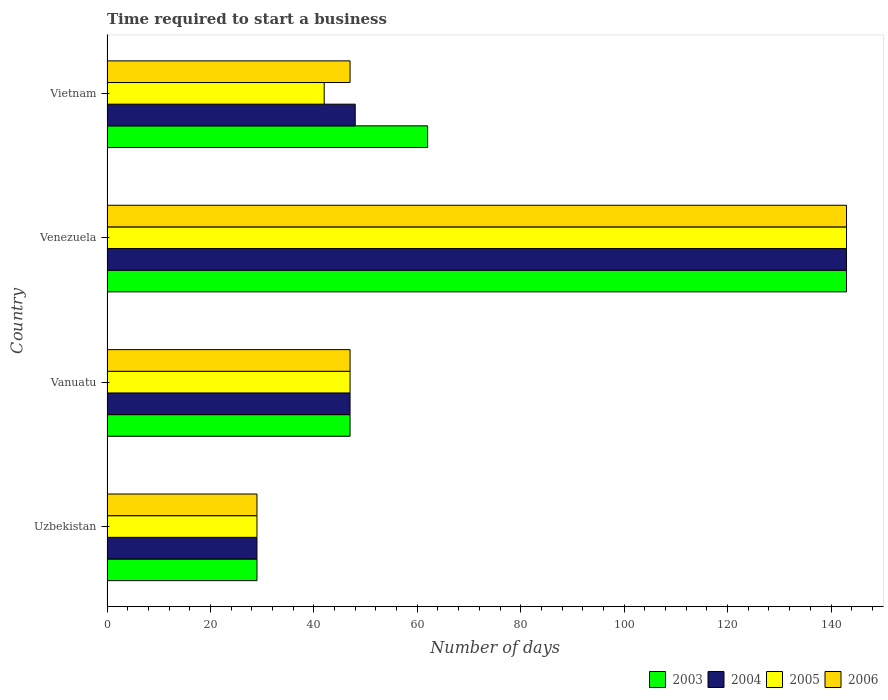Are the number of bars per tick equal to the number of legend labels?
Keep it short and to the point. Yes. Are the number of bars on each tick of the Y-axis equal?
Keep it short and to the point. Yes. How many bars are there on the 3rd tick from the bottom?
Provide a succinct answer. 4. What is the label of the 1st group of bars from the top?
Ensure brevity in your answer.  Vietnam. What is the number of days required to start a business in 2005 in Venezuela?
Provide a succinct answer. 143. Across all countries, what is the maximum number of days required to start a business in 2003?
Offer a very short reply. 143. In which country was the number of days required to start a business in 2003 maximum?
Keep it short and to the point. Venezuela. In which country was the number of days required to start a business in 2005 minimum?
Provide a succinct answer. Uzbekistan. What is the total number of days required to start a business in 2006 in the graph?
Offer a very short reply. 266. What is the difference between the number of days required to start a business in 2004 in Venezuela and that in Vietnam?
Give a very brief answer. 95. What is the difference between the number of days required to start a business in 2006 in Uzbekistan and the number of days required to start a business in 2003 in Vanuatu?
Offer a very short reply. -18. What is the average number of days required to start a business in 2006 per country?
Offer a terse response. 66.5. What is the difference between the number of days required to start a business in 2003 and number of days required to start a business in 2006 in Vanuatu?
Keep it short and to the point. 0. What is the ratio of the number of days required to start a business in 2004 in Uzbekistan to that in Venezuela?
Ensure brevity in your answer.  0.2. Is the difference between the number of days required to start a business in 2003 in Uzbekistan and Vanuatu greater than the difference between the number of days required to start a business in 2006 in Uzbekistan and Vanuatu?
Give a very brief answer. No. What is the difference between the highest and the second highest number of days required to start a business in 2005?
Offer a very short reply. 96. What is the difference between the highest and the lowest number of days required to start a business in 2003?
Provide a succinct answer. 114. In how many countries, is the number of days required to start a business in 2005 greater than the average number of days required to start a business in 2005 taken over all countries?
Give a very brief answer. 1. Is it the case that in every country, the sum of the number of days required to start a business in 2003 and number of days required to start a business in 2006 is greater than the sum of number of days required to start a business in 2005 and number of days required to start a business in 2004?
Provide a succinct answer. No. What does the 3rd bar from the bottom in Vietnam represents?
Ensure brevity in your answer.  2005. How many countries are there in the graph?
Give a very brief answer. 4. What is the difference between two consecutive major ticks on the X-axis?
Your response must be concise. 20. Does the graph contain any zero values?
Offer a very short reply. No. Where does the legend appear in the graph?
Make the answer very short. Bottom right. How many legend labels are there?
Keep it short and to the point. 4. How are the legend labels stacked?
Your answer should be compact. Horizontal. What is the title of the graph?
Provide a succinct answer. Time required to start a business. Does "2012" appear as one of the legend labels in the graph?
Give a very brief answer. No. What is the label or title of the X-axis?
Provide a short and direct response. Number of days. What is the Number of days in 2003 in Uzbekistan?
Provide a short and direct response. 29. What is the Number of days in 2004 in Uzbekistan?
Offer a very short reply. 29. What is the Number of days in 2006 in Uzbekistan?
Provide a succinct answer. 29. What is the Number of days of 2005 in Vanuatu?
Offer a very short reply. 47. What is the Number of days of 2003 in Venezuela?
Provide a succinct answer. 143. What is the Number of days of 2004 in Venezuela?
Your answer should be compact. 143. What is the Number of days of 2005 in Venezuela?
Your response must be concise. 143. What is the Number of days in 2006 in Venezuela?
Provide a succinct answer. 143. What is the Number of days in 2003 in Vietnam?
Your answer should be compact. 62. Across all countries, what is the maximum Number of days of 2003?
Your response must be concise. 143. Across all countries, what is the maximum Number of days of 2004?
Ensure brevity in your answer.  143. Across all countries, what is the maximum Number of days of 2005?
Your answer should be very brief. 143. Across all countries, what is the maximum Number of days in 2006?
Give a very brief answer. 143. Across all countries, what is the minimum Number of days in 2006?
Ensure brevity in your answer.  29. What is the total Number of days in 2003 in the graph?
Give a very brief answer. 281. What is the total Number of days of 2004 in the graph?
Keep it short and to the point. 267. What is the total Number of days of 2005 in the graph?
Give a very brief answer. 261. What is the total Number of days in 2006 in the graph?
Keep it short and to the point. 266. What is the difference between the Number of days of 2003 in Uzbekistan and that in Vanuatu?
Offer a terse response. -18. What is the difference between the Number of days in 2005 in Uzbekistan and that in Vanuatu?
Give a very brief answer. -18. What is the difference between the Number of days of 2006 in Uzbekistan and that in Vanuatu?
Your response must be concise. -18. What is the difference between the Number of days of 2003 in Uzbekistan and that in Venezuela?
Give a very brief answer. -114. What is the difference between the Number of days in 2004 in Uzbekistan and that in Venezuela?
Offer a terse response. -114. What is the difference between the Number of days in 2005 in Uzbekistan and that in Venezuela?
Keep it short and to the point. -114. What is the difference between the Number of days of 2006 in Uzbekistan and that in Venezuela?
Your answer should be very brief. -114. What is the difference between the Number of days of 2003 in Uzbekistan and that in Vietnam?
Your answer should be very brief. -33. What is the difference between the Number of days of 2005 in Uzbekistan and that in Vietnam?
Your answer should be very brief. -13. What is the difference between the Number of days of 2006 in Uzbekistan and that in Vietnam?
Give a very brief answer. -18. What is the difference between the Number of days of 2003 in Vanuatu and that in Venezuela?
Offer a terse response. -96. What is the difference between the Number of days of 2004 in Vanuatu and that in Venezuela?
Your response must be concise. -96. What is the difference between the Number of days of 2005 in Vanuatu and that in Venezuela?
Offer a terse response. -96. What is the difference between the Number of days in 2006 in Vanuatu and that in Venezuela?
Keep it short and to the point. -96. What is the difference between the Number of days in 2003 in Vanuatu and that in Vietnam?
Your answer should be compact. -15. What is the difference between the Number of days in 2004 in Vanuatu and that in Vietnam?
Your answer should be very brief. -1. What is the difference between the Number of days of 2005 in Venezuela and that in Vietnam?
Your answer should be compact. 101. What is the difference between the Number of days in 2006 in Venezuela and that in Vietnam?
Give a very brief answer. 96. What is the difference between the Number of days in 2003 in Uzbekistan and the Number of days in 2005 in Vanuatu?
Your answer should be very brief. -18. What is the difference between the Number of days of 2003 in Uzbekistan and the Number of days of 2006 in Vanuatu?
Keep it short and to the point. -18. What is the difference between the Number of days in 2004 in Uzbekistan and the Number of days in 2006 in Vanuatu?
Your response must be concise. -18. What is the difference between the Number of days in 2003 in Uzbekistan and the Number of days in 2004 in Venezuela?
Your answer should be compact. -114. What is the difference between the Number of days of 2003 in Uzbekistan and the Number of days of 2005 in Venezuela?
Your answer should be compact. -114. What is the difference between the Number of days in 2003 in Uzbekistan and the Number of days in 2006 in Venezuela?
Provide a succinct answer. -114. What is the difference between the Number of days of 2004 in Uzbekistan and the Number of days of 2005 in Venezuela?
Provide a short and direct response. -114. What is the difference between the Number of days of 2004 in Uzbekistan and the Number of days of 2006 in Venezuela?
Your answer should be very brief. -114. What is the difference between the Number of days in 2005 in Uzbekistan and the Number of days in 2006 in Venezuela?
Your answer should be very brief. -114. What is the difference between the Number of days of 2003 in Uzbekistan and the Number of days of 2004 in Vietnam?
Your answer should be very brief. -19. What is the difference between the Number of days in 2003 in Uzbekistan and the Number of days in 2005 in Vietnam?
Make the answer very short. -13. What is the difference between the Number of days of 2003 in Uzbekistan and the Number of days of 2006 in Vietnam?
Your response must be concise. -18. What is the difference between the Number of days of 2004 in Uzbekistan and the Number of days of 2005 in Vietnam?
Your answer should be very brief. -13. What is the difference between the Number of days in 2004 in Uzbekistan and the Number of days in 2006 in Vietnam?
Your response must be concise. -18. What is the difference between the Number of days in 2003 in Vanuatu and the Number of days in 2004 in Venezuela?
Provide a succinct answer. -96. What is the difference between the Number of days of 2003 in Vanuatu and the Number of days of 2005 in Venezuela?
Offer a very short reply. -96. What is the difference between the Number of days of 2003 in Vanuatu and the Number of days of 2006 in Venezuela?
Provide a short and direct response. -96. What is the difference between the Number of days in 2004 in Vanuatu and the Number of days in 2005 in Venezuela?
Offer a very short reply. -96. What is the difference between the Number of days in 2004 in Vanuatu and the Number of days in 2006 in Venezuela?
Your response must be concise. -96. What is the difference between the Number of days in 2005 in Vanuatu and the Number of days in 2006 in Venezuela?
Provide a succinct answer. -96. What is the difference between the Number of days of 2003 in Vanuatu and the Number of days of 2004 in Vietnam?
Your response must be concise. -1. What is the difference between the Number of days of 2004 in Vanuatu and the Number of days of 2006 in Vietnam?
Your answer should be compact. 0. What is the difference between the Number of days in 2003 in Venezuela and the Number of days in 2004 in Vietnam?
Provide a short and direct response. 95. What is the difference between the Number of days in 2003 in Venezuela and the Number of days in 2005 in Vietnam?
Your answer should be compact. 101. What is the difference between the Number of days in 2003 in Venezuela and the Number of days in 2006 in Vietnam?
Make the answer very short. 96. What is the difference between the Number of days in 2004 in Venezuela and the Number of days in 2005 in Vietnam?
Offer a very short reply. 101. What is the difference between the Number of days of 2004 in Venezuela and the Number of days of 2006 in Vietnam?
Keep it short and to the point. 96. What is the difference between the Number of days in 2005 in Venezuela and the Number of days in 2006 in Vietnam?
Provide a short and direct response. 96. What is the average Number of days of 2003 per country?
Provide a succinct answer. 70.25. What is the average Number of days of 2004 per country?
Provide a short and direct response. 66.75. What is the average Number of days in 2005 per country?
Your answer should be compact. 65.25. What is the average Number of days of 2006 per country?
Provide a short and direct response. 66.5. What is the difference between the Number of days of 2003 and Number of days of 2004 in Uzbekistan?
Ensure brevity in your answer.  0. What is the difference between the Number of days in 2003 and Number of days in 2005 in Uzbekistan?
Offer a terse response. 0. What is the difference between the Number of days of 2003 and Number of days of 2006 in Uzbekistan?
Your answer should be compact. 0. What is the difference between the Number of days of 2004 and Number of days of 2005 in Uzbekistan?
Provide a succinct answer. 0. What is the difference between the Number of days of 2003 and Number of days of 2006 in Vanuatu?
Make the answer very short. 0. What is the difference between the Number of days in 2004 and Number of days in 2006 in Vanuatu?
Ensure brevity in your answer.  0. What is the difference between the Number of days of 2003 and Number of days of 2005 in Venezuela?
Ensure brevity in your answer.  0. What is the difference between the Number of days in 2003 and Number of days in 2006 in Venezuela?
Keep it short and to the point. 0. What is the difference between the Number of days in 2004 and Number of days in 2006 in Venezuela?
Offer a terse response. 0. What is the difference between the Number of days in 2005 and Number of days in 2006 in Venezuela?
Your response must be concise. 0. What is the difference between the Number of days in 2003 and Number of days in 2006 in Vietnam?
Offer a terse response. 15. What is the difference between the Number of days in 2004 and Number of days in 2006 in Vietnam?
Your answer should be compact. 1. What is the ratio of the Number of days of 2003 in Uzbekistan to that in Vanuatu?
Your answer should be compact. 0.62. What is the ratio of the Number of days in 2004 in Uzbekistan to that in Vanuatu?
Keep it short and to the point. 0.62. What is the ratio of the Number of days of 2005 in Uzbekistan to that in Vanuatu?
Make the answer very short. 0.62. What is the ratio of the Number of days in 2006 in Uzbekistan to that in Vanuatu?
Provide a succinct answer. 0.62. What is the ratio of the Number of days of 2003 in Uzbekistan to that in Venezuela?
Provide a succinct answer. 0.2. What is the ratio of the Number of days of 2004 in Uzbekistan to that in Venezuela?
Provide a succinct answer. 0.2. What is the ratio of the Number of days of 2005 in Uzbekistan to that in Venezuela?
Your answer should be very brief. 0.2. What is the ratio of the Number of days of 2006 in Uzbekistan to that in Venezuela?
Give a very brief answer. 0.2. What is the ratio of the Number of days in 2003 in Uzbekistan to that in Vietnam?
Provide a short and direct response. 0.47. What is the ratio of the Number of days in 2004 in Uzbekistan to that in Vietnam?
Your response must be concise. 0.6. What is the ratio of the Number of days of 2005 in Uzbekistan to that in Vietnam?
Make the answer very short. 0.69. What is the ratio of the Number of days in 2006 in Uzbekistan to that in Vietnam?
Keep it short and to the point. 0.62. What is the ratio of the Number of days in 2003 in Vanuatu to that in Venezuela?
Your response must be concise. 0.33. What is the ratio of the Number of days in 2004 in Vanuatu to that in Venezuela?
Ensure brevity in your answer.  0.33. What is the ratio of the Number of days of 2005 in Vanuatu to that in Venezuela?
Your response must be concise. 0.33. What is the ratio of the Number of days in 2006 in Vanuatu to that in Venezuela?
Your response must be concise. 0.33. What is the ratio of the Number of days of 2003 in Vanuatu to that in Vietnam?
Keep it short and to the point. 0.76. What is the ratio of the Number of days of 2004 in Vanuatu to that in Vietnam?
Your response must be concise. 0.98. What is the ratio of the Number of days in 2005 in Vanuatu to that in Vietnam?
Your answer should be compact. 1.12. What is the ratio of the Number of days of 2003 in Venezuela to that in Vietnam?
Your response must be concise. 2.31. What is the ratio of the Number of days in 2004 in Venezuela to that in Vietnam?
Offer a terse response. 2.98. What is the ratio of the Number of days in 2005 in Venezuela to that in Vietnam?
Provide a succinct answer. 3.4. What is the ratio of the Number of days of 2006 in Venezuela to that in Vietnam?
Give a very brief answer. 3.04. What is the difference between the highest and the second highest Number of days of 2005?
Provide a succinct answer. 96. What is the difference between the highest and the second highest Number of days of 2006?
Your answer should be very brief. 96. What is the difference between the highest and the lowest Number of days in 2003?
Provide a short and direct response. 114. What is the difference between the highest and the lowest Number of days of 2004?
Ensure brevity in your answer.  114. What is the difference between the highest and the lowest Number of days of 2005?
Offer a very short reply. 114. What is the difference between the highest and the lowest Number of days in 2006?
Provide a short and direct response. 114. 